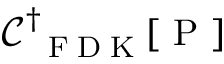Convert formula to latex. <formula><loc_0><loc_0><loc_500><loc_500>\mathcal { C } _ { F D K } ^ { \dagger } [ P ]</formula> 